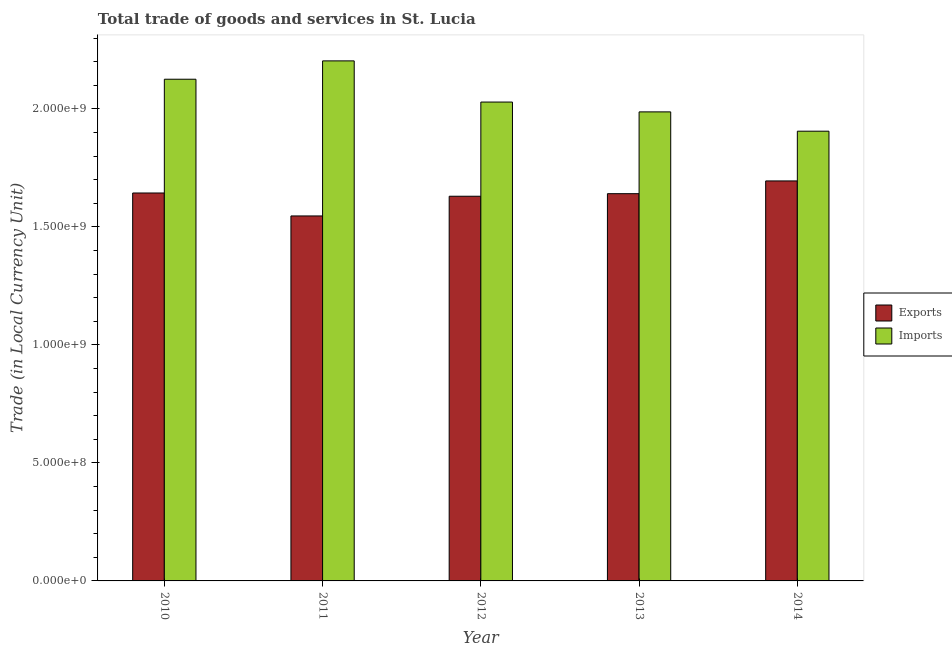How many different coloured bars are there?
Give a very brief answer. 2. How many bars are there on the 4th tick from the left?
Provide a short and direct response. 2. How many bars are there on the 4th tick from the right?
Provide a short and direct response. 2. In how many cases, is the number of bars for a given year not equal to the number of legend labels?
Your answer should be compact. 0. What is the imports of goods and services in 2013?
Your response must be concise. 1.99e+09. Across all years, what is the maximum export of goods and services?
Keep it short and to the point. 1.70e+09. Across all years, what is the minimum export of goods and services?
Your response must be concise. 1.55e+09. In which year was the imports of goods and services minimum?
Ensure brevity in your answer.  2014. What is the total export of goods and services in the graph?
Ensure brevity in your answer.  8.16e+09. What is the difference between the imports of goods and services in 2012 and that in 2014?
Keep it short and to the point. 1.23e+08. What is the difference between the export of goods and services in 2014 and the imports of goods and services in 2010?
Make the answer very short. 5.11e+07. What is the average imports of goods and services per year?
Your response must be concise. 2.05e+09. In how many years, is the imports of goods and services greater than 400000000 LCU?
Provide a short and direct response. 5. What is the ratio of the imports of goods and services in 2011 to that in 2014?
Make the answer very short. 1.16. Is the export of goods and services in 2013 less than that in 2014?
Keep it short and to the point. Yes. What is the difference between the highest and the second highest imports of goods and services?
Make the answer very short. 7.78e+07. What is the difference between the highest and the lowest export of goods and services?
Your answer should be compact. 1.48e+08. What does the 2nd bar from the left in 2012 represents?
Ensure brevity in your answer.  Imports. What does the 1st bar from the right in 2010 represents?
Offer a terse response. Imports. How many bars are there?
Provide a succinct answer. 10. Are all the bars in the graph horizontal?
Your answer should be compact. No. How many legend labels are there?
Provide a succinct answer. 2. How are the legend labels stacked?
Ensure brevity in your answer.  Vertical. What is the title of the graph?
Your answer should be compact. Total trade of goods and services in St. Lucia. What is the label or title of the X-axis?
Make the answer very short. Year. What is the label or title of the Y-axis?
Offer a very short reply. Trade (in Local Currency Unit). What is the Trade (in Local Currency Unit) in Exports in 2010?
Give a very brief answer. 1.64e+09. What is the Trade (in Local Currency Unit) of Imports in 2010?
Give a very brief answer. 2.13e+09. What is the Trade (in Local Currency Unit) in Exports in 2011?
Ensure brevity in your answer.  1.55e+09. What is the Trade (in Local Currency Unit) in Imports in 2011?
Make the answer very short. 2.20e+09. What is the Trade (in Local Currency Unit) of Exports in 2012?
Ensure brevity in your answer.  1.63e+09. What is the Trade (in Local Currency Unit) of Imports in 2012?
Make the answer very short. 2.03e+09. What is the Trade (in Local Currency Unit) in Exports in 2013?
Give a very brief answer. 1.64e+09. What is the Trade (in Local Currency Unit) of Imports in 2013?
Your answer should be very brief. 1.99e+09. What is the Trade (in Local Currency Unit) of Exports in 2014?
Give a very brief answer. 1.70e+09. What is the Trade (in Local Currency Unit) in Imports in 2014?
Provide a succinct answer. 1.91e+09. Across all years, what is the maximum Trade (in Local Currency Unit) of Exports?
Offer a very short reply. 1.70e+09. Across all years, what is the maximum Trade (in Local Currency Unit) in Imports?
Offer a terse response. 2.20e+09. Across all years, what is the minimum Trade (in Local Currency Unit) in Exports?
Offer a terse response. 1.55e+09. Across all years, what is the minimum Trade (in Local Currency Unit) in Imports?
Make the answer very short. 1.91e+09. What is the total Trade (in Local Currency Unit) in Exports in the graph?
Offer a very short reply. 8.16e+09. What is the total Trade (in Local Currency Unit) in Imports in the graph?
Keep it short and to the point. 1.03e+1. What is the difference between the Trade (in Local Currency Unit) of Exports in 2010 and that in 2011?
Offer a very short reply. 9.73e+07. What is the difference between the Trade (in Local Currency Unit) of Imports in 2010 and that in 2011?
Make the answer very short. -7.78e+07. What is the difference between the Trade (in Local Currency Unit) in Exports in 2010 and that in 2012?
Give a very brief answer. 1.38e+07. What is the difference between the Trade (in Local Currency Unit) in Imports in 2010 and that in 2012?
Offer a very short reply. 9.67e+07. What is the difference between the Trade (in Local Currency Unit) in Exports in 2010 and that in 2013?
Give a very brief answer. 2.95e+06. What is the difference between the Trade (in Local Currency Unit) of Imports in 2010 and that in 2013?
Make the answer very short. 1.38e+08. What is the difference between the Trade (in Local Currency Unit) of Exports in 2010 and that in 2014?
Your answer should be compact. -5.11e+07. What is the difference between the Trade (in Local Currency Unit) in Imports in 2010 and that in 2014?
Make the answer very short. 2.20e+08. What is the difference between the Trade (in Local Currency Unit) in Exports in 2011 and that in 2012?
Offer a terse response. -8.35e+07. What is the difference between the Trade (in Local Currency Unit) in Imports in 2011 and that in 2012?
Make the answer very short. 1.75e+08. What is the difference between the Trade (in Local Currency Unit) of Exports in 2011 and that in 2013?
Give a very brief answer. -9.43e+07. What is the difference between the Trade (in Local Currency Unit) of Imports in 2011 and that in 2013?
Offer a very short reply. 2.16e+08. What is the difference between the Trade (in Local Currency Unit) in Exports in 2011 and that in 2014?
Keep it short and to the point. -1.48e+08. What is the difference between the Trade (in Local Currency Unit) in Imports in 2011 and that in 2014?
Keep it short and to the point. 2.98e+08. What is the difference between the Trade (in Local Currency Unit) of Exports in 2012 and that in 2013?
Offer a very short reply. -1.08e+07. What is the difference between the Trade (in Local Currency Unit) in Imports in 2012 and that in 2013?
Your answer should be compact. 4.16e+07. What is the difference between the Trade (in Local Currency Unit) in Exports in 2012 and that in 2014?
Provide a short and direct response. -6.49e+07. What is the difference between the Trade (in Local Currency Unit) in Imports in 2012 and that in 2014?
Make the answer very short. 1.23e+08. What is the difference between the Trade (in Local Currency Unit) in Exports in 2013 and that in 2014?
Your answer should be very brief. -5.40e+07. What is the difference between the Trade (in Local Currency Unit) in Imports in 2013 and that in 2014?
Your answer should be very brief. 8.19e+07. What is the difference between the Trade (in Local Currency Unit) of Exports in 2010 and the Trade (in Local Currency Unit) of Imports in 2011?
Provide a succinct answer. -5.60e+08. What is the difference between the Trade (in Local Currency Unit) in Exports in 2010 and the Trade (in Local Currency Unit) in Imports in 2012?
Ensure brevity in your answer.  -3.85e+08. What is the difference between the Trade (in Local Currency Unit) of Exports in 2010 and the Trade (in Local Currency Unit) of Imports in 2013?
Provide a succinct answer. -3.44e+08. What is the difference between the Trade (in Local Currency Unit) in Exports in 2010 and the Trade (in Local Currency Unit) in Imports in 2014?
Keep it short and to the point. -2.62e+08. What is the difference between the Trade (in Local Currency Unit) in Exports in 2011 and the Trade (in Local Currency Unit) in Imports in 2012?
Offer a very short reply. -4.83e+08. What is the difference between the Trade (in Local Currency Unit) in Exports in 2011 and the Trade (in Local Currency Unit) in Imports in 2013?
Ensure brevity in your answer.  -4.41e+08. What is the difference between the Trade (in Local Currency Unit) in Exports in 2011 and the Trade (in Local Currency Unit) in Imports in 2014?
Your response must be concise. -3.59e+08. What is the difference between the Trade (in Local Currency Unit) of Exports in 2012 and the Trade (in Local Currency Unit) of Imports in 2013?
Offer a very short reply. -3.58e+08. What is the difference between the Trade (in Local Currency Unit) in Exports in 2012 and the Trade (in Local Currency Unit) in Imports in 2014?
Offer a terse response. -2.76e+08. What is the difference between the Trade (in Local Currency Unit) of Exports in 2013 and the Trade (in Local Currency Unit) of Imports in 2014?
Make the answer very short. -2.65e+08. What is the average Trade (in Local Currency Unit) in Exports per year?
Your response must be concise. 1.63e+09. What is the average Trade (in Local Currency Unit) in Imports per year?
Provide a succinct answer. 2.05e+09. In the year 2010, what is the difference between the Trade (in Local Currency Unit) of Exports and Trade (in Local Currency Unit) of Imports?
Give a very brief answer. -4.82e+08. In the year 2011, what is the difference between the Trade (in Local Currency Unit) in Exports and Trade (in Local Currency Unit) in Imports?
Your answer should be very brief. -6.57e+08. In the year 2012, what is the difference between the Trade (in Local Currency Unit) of Exports and Trade (in Local Currency Unit) of Imports?
Offer a very short reply. -3.99e+08. In the year 2013, what is the difference between the Trade (in Local Currency Unit) in Exports and Trade (in Local Currency Unit) in Imports?
Give a very brief answer. -3.47e+08. In the year 2014, what is the difference between the Trade (in Local Currency Unit) in Exports and Trade (in Local Currency Unit) in Imports?
Provide a short and direct response. -2.11e+08. What is the ratio of the Trade (in Local Currency Unit) in Exports in 2010 to that in 2011?
Keep it short and to the point. 1.06. What is the ratio of the Trade (in Local Currency Unit) of Imports in 2010 to that in 2011?
Provide a succinct answer. 0.96. What is the ratio of the Trade (in Local Currency Unit) of Exports in 2010 to that in 2012?
Your answer should be compact. 1.01. What is the ratio of the Trade (in Local Currency Unit) of Imports in 2010 to that in 2012?
Offer a very short reply. 1.05. What is the ratio of the Trade (in Local Currency Unit) in Imports in 2010 to that in 2013?
Give a very brief answer. 1.07. What is the ratio of the Trade (in Local Currency Unit) of Exports in 2010 to that in 2014?
Provide a succinct answer. 0.97. What is the ratio of the Trade (in Local Currency Unit) of Imports in 2010 to that in 2014?
Your response must be concise. 1.12. What is the ratio of the Trade (in Local Currency Unit) of Exports in 2011 to that in 2012?
Your response must be concise. 0.95. What is the ratio of the Trade (in Local Currency Unit) in Imports in 2011 to that in 2012?
Provide a short and direct response. 1.09. What is the ratio of the Trade (in Local Currency Unit) in Exports in 2011 to that in 2013?
Offer a very short reply. 0.94. What is the ratio of the Trade (in Local Currency Unit) in Imports in 2011 to that in 2013?
Offer a terse response. 1.11. What is the ratio of the Trade (in Local Currency Unit) in Exports in 2011 to that in 2014?
Keep it short and to the point. 0.91. What is the ratio of the Trade (in Local Currency Unit) of Imports in 2011 to that in 2014?
Your answer should be very brief. 1.16. What is the ratio of the Trade (in Local Currency Unit) of Exports in 2012 to that in 2013?
Give a very brief answer. 0.99. What is the ratio of the Trade (in Local Currency Unit) in Imports in 2012 to that in 2013?
Your answer should be very brief. 1.02. What is the ratio of the Trade (in Local Currency Unit) of Exports in 2012 to that in 2014?
Your answer should be very brief. 0.96. What is the ratio of the Trade (in Local Currency Unit) of Imports in 2012 to that in 2014?
Make the answer very short. 1.06. What is the ratio of the Trade (in Local Currency Unit) in Exports in 2013 to that in 2014?
Make the answer very short. 0.97. What is the ratio of the Trade (in Local Currency Unit) of Imports in 2013 to that in 2014?
Offer a very short reply. 1.04. What is the difference between the highest and the second highest Trade (in Local Currency Unit) of Exports?
Make the answer very short. 5.11e+07. What is the difference between the highest and the second highest Trade (in Local Currency Unit) of Imports?
Ensure brevity in your answer.  7.78e+07. What is the difference between the highest and the lowest Trade (in Local Currency Unit) in Exports?
Offer a terse response. 1.48e+08. What is the difference between the highest and the lowest Trade (in Local Currency Unit) in Imports?
Provide a succinct answer. 2.98e+08. 